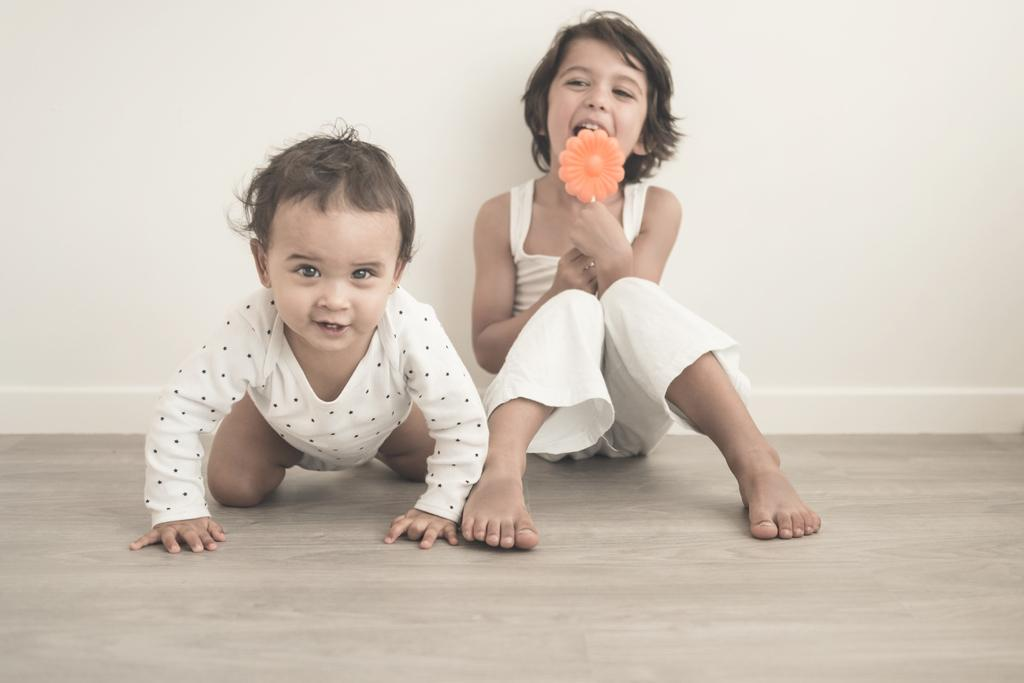How many kids are in the image? There are kids in the image, but the exact number is not specified. What is the kid holding in the image? One of the kids is holding an object in the image. What can be seen in the background of the image? There is a wall in the background of the image. What is visible at the bottom of the image? There is a floor visible at the bottom of the image. What type of animal can be seen in the basket in the image? There is no basket or animal present in the image. How does the tramp contribute to the image? There is no tramp present in the image. 